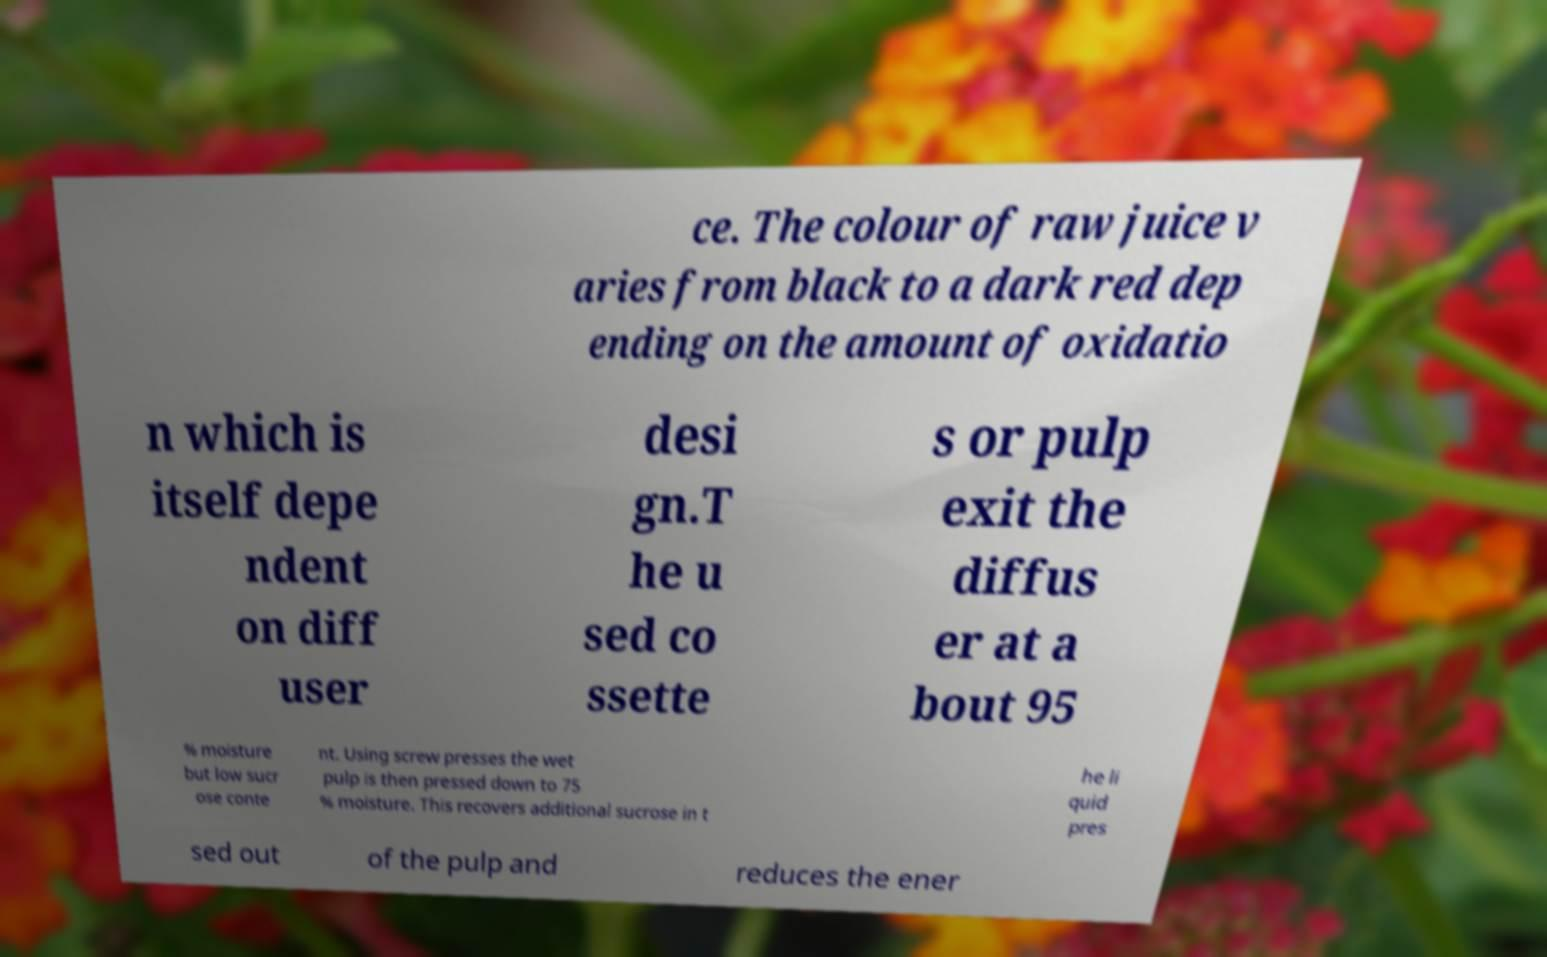I need the written content from this picture converted into text. Can you do that? ce. The colour of raw juice v aries from black to a dark red dep ending on the amount of oxidatio n which is itself depe ndent on diff user desi gn.T he u sed co ssette s or pulp exit the diffus er at a bout 95 % moisture but low sucr ose conte nt. Using screw presses the wet pulp is then pressed down to 75 % moisture. This recovers additional sucrose in t he li quid pres sed out of the pulp and reduces the ener 